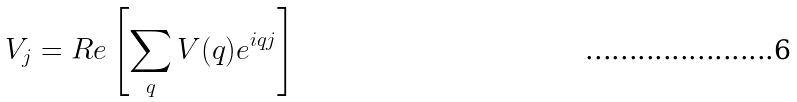Convert formula to latex. <formula><loc_0><loc_0><loc_500><loc_500>V _ { j } = R e \left [ \sum _ { q } V ( q ) e ^ { i q j } \right ]</formula> 